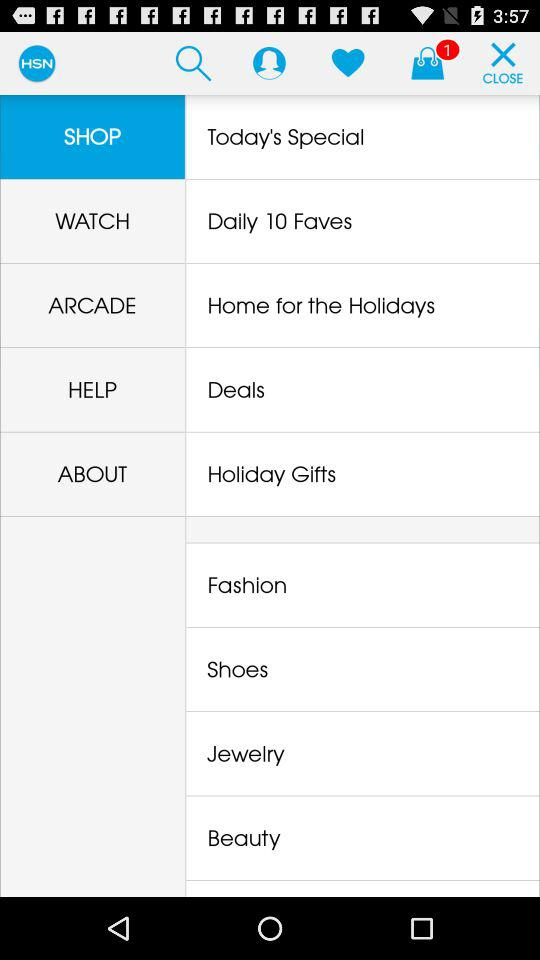Which option is highlighted? The highlighted option is "Shop". 